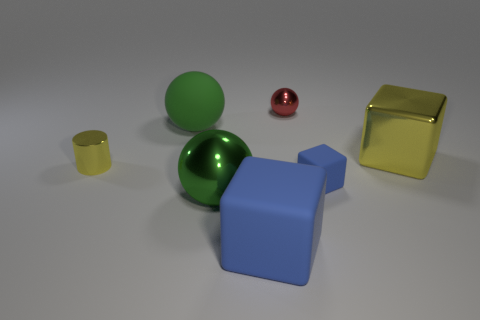There is a small rubber object; what shape is it?
Your response must be concise. Cube. How many metal things are right of the big green sphere that is in front of the yellow metal object left of the rubber ball?
Your answer should be very brief. 2. What number of other things are the same material as the small ball?
Make the answer very short. 3. There is another green sphere that is the same size as the green rubber ball; what material is it?
Provide a succinct answer. Metal. Is the color of the big metal object that is on the left side of the big yellow metal block the same as the tiny cylinder in front of the tiny sphere?
Give a very brief answer. No. Are there any tiny yellow metallic objects of the same shape as the green rubber thing?
Give a very brief answer. No. There is a yellow thing that is the same size as the green metal object; what shape is it?
Make the answer very short. Cube. How many big rubber cubes have the same color as the tiny rubber object?
Give a very brief answer. 1. How big is the blue rubber block on the right side of the small red sphere?
Provide a short and direct response. Small. How many green metallic objects have the same size as the yellow block?
Provide a short and direct response. 1. 